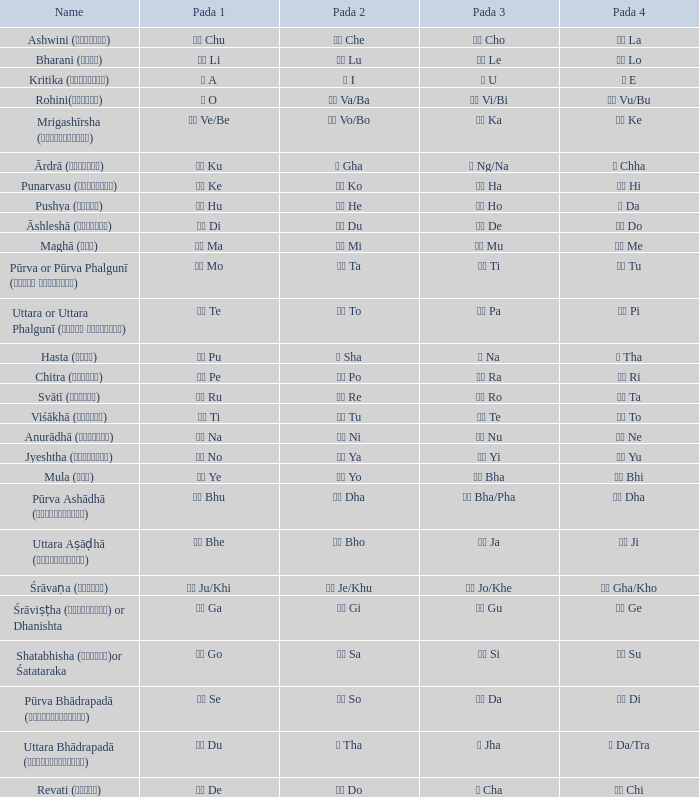Which pada 3 has a pada 2 of चे che? चो Cho. 